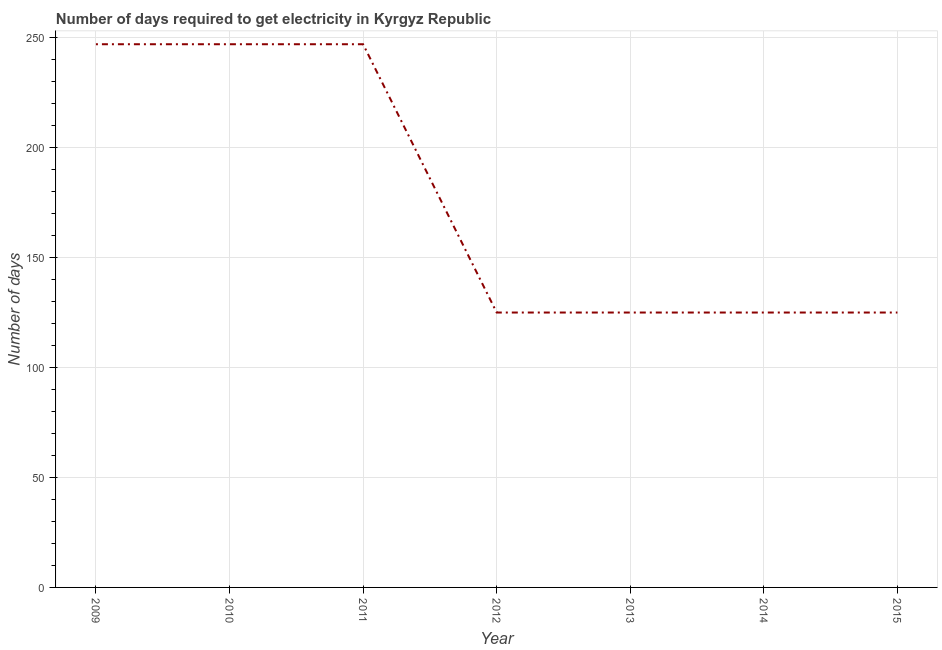What is the time to get electricity in 2014?
Your answer should be very brief. 125. Across all years, what is the maximum time to get electricity?
Give a very brief answer. 247. Across all years, what is the minimum time to get electricity?
Give a very brief answer. 125. In which year was the time to get electricity maximum?
Your answer should be compact. 2009. What is the sum of the time to get electricity?
Your response must be concise. 1241. What is the difference between the time to get electricity in 2009 and 2014?
Provide a short and direct response. 122. What is the average time to get electricity per year?
Your response must be concise. 177.29. What is the median time to get electricity?
Ensure brevity in your answer.  125. What is the ratio of the time to get electricity in 2009 to that in 2012?
Offer a terse response. 1.98. Is the time to get electricity in 2012 less than that in 2014?
Provide a short and direct response. No. Is the sum of the time to get electricity in 2012 and 2015 greater than the maximum time to get electricity across all years?
Offer a terse response. Yes. What is the difference between the highest and the lowest time to get electricity?
Your answer should be very brief. 122. Does the time to get electricity monotonically increase over the years?
Make the answer very short. No. How many years are there in the graph?
Give a very brief answer. 7. What is the difference between two consecutive major ticks on the Y-axis?
Make the answer very short. 50. Does the graph contain any zero values?
Provide a short and direct response. No. What is the title of the graph?
Provide a succinct answer. Number of days required to get electricity in Kyrgyz Republic. What is the label or title of the X-axis?
Provide a short and direct response. Year. What is the label or title of the Y-axis?
Give a very brief answer. Number of days. What is the Number of days in 2009?
Offer a very short reply. 247. What is the Number of days of 2010?
Your response must be concise. 247. What is the Number of days in 2011?
Your answer should be compact. 247. What is the Number of days in 2012?
Your response must be concise. 125. What is the Number of days in 2013?
Provide a short and direct response. 125. What is the Number of days of 2014?
Your answer should be very brief. 125. What is the Number of days in 2015?
Your answer should be compact. 125. What is the difference between the Number of days in 2009 and 2010?
Provide a succinct answer. 0. What is the difference between the Number of days in 2009 and 2012?
Your answer should be very brief. 122. What is the difference between the Number of days in 2009 and 2013?
Offer a terse response. 122. What is the difference between the Number of days in 2009 and 2014?
Keep it short and to the point. 122. What is the difference between the Number of days in 2009 and 2015?
Give a very brief answer. 122. What is the difference between the Number of days in 2010 and 2012?
Your response must be concise. 122. What is the difference between the Number of days in 2010 and 2013?
Keep it short and to the point. 122. What is the difference between the Number of days in 2010 and 2014?
Give a very brief answer. 122. What is the difference between the Number of days in 2010 and 2015?
Ensure brevity in your answer.  122. What is the difference between the Number of days in 2011 and 2012?
Your response must be concise. 122. What is the difference between the Number of days in 2011 and 2013?
Your answer should be compact. 122. What is the difference between the Number of days in 2011 and 2014?
Your answer should be compact. 122. What is the difference between the Number of days in 2011 and 2015?
Your response must be concise. 122. What is the difference between the Number of days in 2012 and 2014?
Offer a very short reply. 0. What is the difference between the Number of days in 2012 and 2015?
Provide a succinct answer. 0. What is the difference between the Number of days in 2013 and 2015?
Provide a short and direct response. 0. What is the difference between the Number of days in 2014 and 2015?
Your answer should be compact. 0. What is the ratio of the Number of days in 2009 to that in 2012?
Offer a very short reply. 1.98. What is the ratio of the Number of days in 2009 to that in 2013?
Ensure brevity in your answer.  1.98. What is the ratio of the Number of days in 2009 to that in 2014?
Your answer should be very brief. 1.98. What is the ratio of the Number of days in 2009 to that in 2015?
Keep it short and to the point. 1.98. What is the ratio of the Number of days in 2010 to that in 2012?
Give a very brief answer. 1.98. What is the ratio of the Number of days in 2010 to that in 2013?
Keep it short and to the point. 1.98. What is the ratio of the Number of days in 2010 to that in 2014?
Provide a short and direct response. 1.98. What is the ratio of the Number of days in 2010 to that in 2015?
Keep it short and to the point. 1.98. What is the ratio of the Number of days in 2011 to that in 2012?
Offer a very short reply. 1.98. What is the ratio of the Number of days in 2011 to that in 2013?
Make the answer very short. 1.98. What is the ratio of the Number of days in 2011 to that in 2014?
Offer a very short reply. 1.98. What is the ratio of the Number of days in 2011 to that in 2015?
Your response must be concise. 1.98. What is the ratio of the Number of days in 2012 to that in 2014?
Your response must be concise. 1. What is the ratio of the Number of days in 2012 to that in 2015?
Your answer should be very brief. 1. What is the ratio of the Number of days in 2013 to that in 2015?
Keep it short and to the point. 1. 